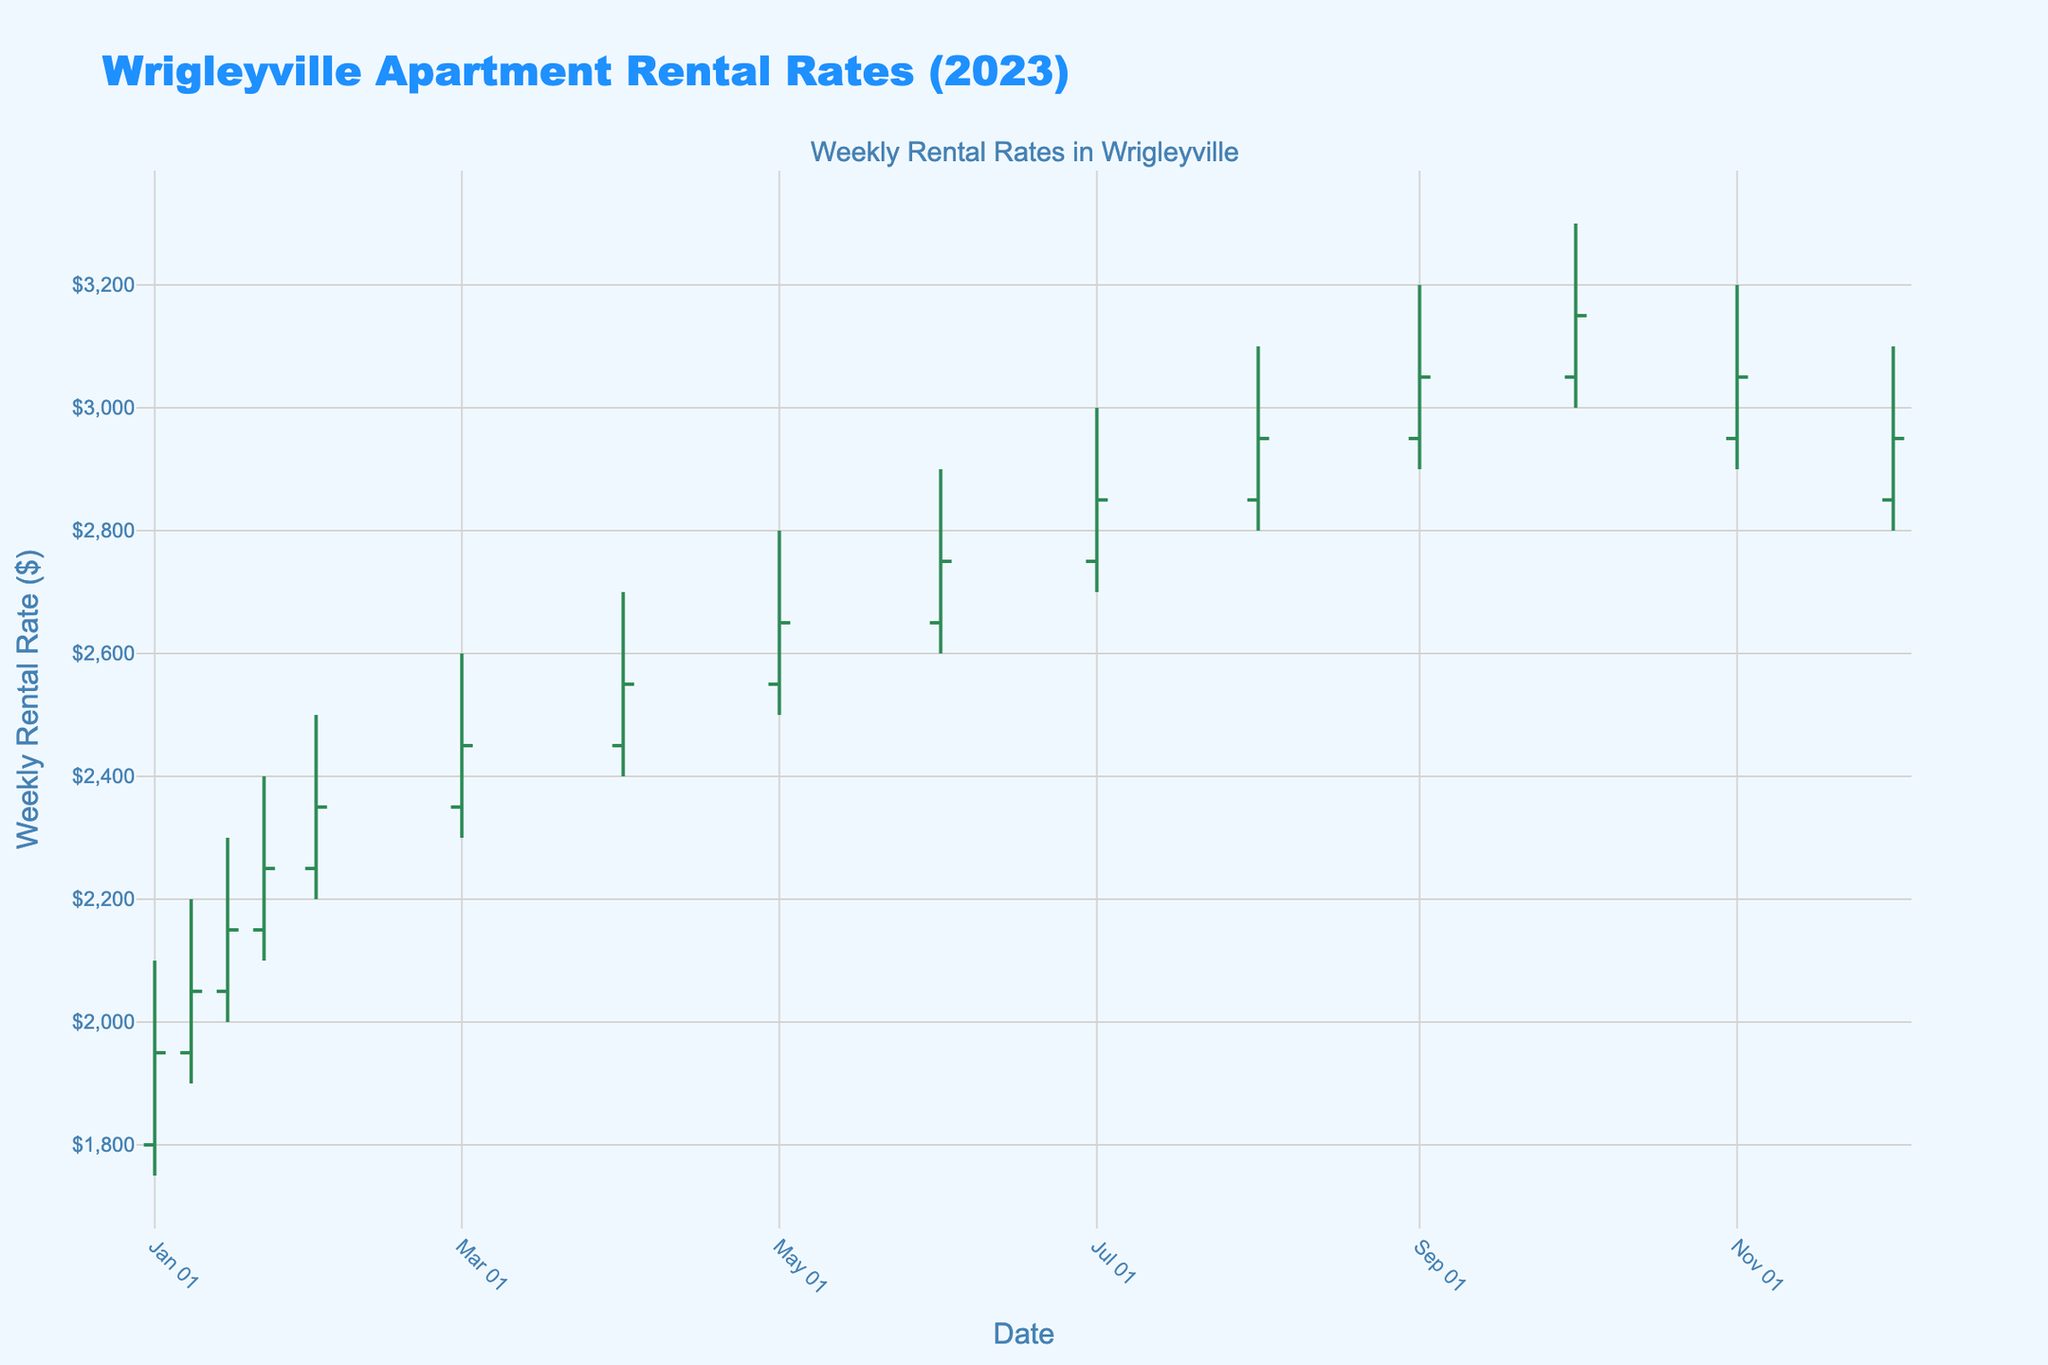What's the title of the figure? The title of the figure is displayed at the top and reads "Wrigleyville Apartment Rental Rates (2023)".
Answer: Wrigleyville Apartment Rental Rates (2023) What is the highest rental rate shown on the chart? The highest rental rate is indicated by the highest point on the chart, which is $3300 in October.
Answer: $3300 During which week did the rental rates first reach $3000? By looking at the figure, the first time the rental rates reach $3000 is during the week of July 1-7.
Answer: Jul 1-7 What is the range (High-Low) of rental rates for the week of Apr 1-7? The high for the week of Apr 1-7 is $2700, and the low is $2400. The range is $2700 - $2400 = $300.
Answer: $300 Which months show a decline in the closing rental rate compared to the previous month? To find the months where the closing rate declined, we look for months where the closing value is lower than the previous month's closing value. This occurs in the months of November and December.
Answer: November and December What is the average closing rental rate from Jan to Dec? Sum up the closing rates from Jan to Dec: 1950 + 2050 + 2150 + 2250 + 2350 + 2450 + 2550 + 2650 + 2750 + 2850 + 2950 + 3050 + 3150 + 3050 + 2950 = 41850. Divide by the 15 weeks: \(41850 / 15 = 2790\).
Answer: $2790 What was the closing rental rate in Feb compared to Mar? The closing rate for Feb 1-7 is $2350 and for Mar 1-7 is $2450. Comparing both: Feb's closing rate is $100 less than Mar's.
Answer: Feb was $100 less How many data points are displayed on the chart? Count the number of weeks displayed; there are 15 intervals, indicating 15 data points.
Answer: 15 Which period shows the highest increase in the closing rental rate? Maximum increase in closing rate appears between Jan 1-7 ($1950) and Oct 1-7 ($3150), a rise of $1200.
Answer: Jan 1-7 to Oct 1-7 By how much did the rental rates increase from Jun 1-7 to Jul 1-7? For Jun 1-7, the closing rate is $2750. For Jul 1-7, it is $2850. The increase is $2850 - $2750 = $100.
Answer: $100 